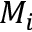Convert formula to latex. <formula><loc_0><loc_0><loc_500><loc_500>M _ { i }</formula> 